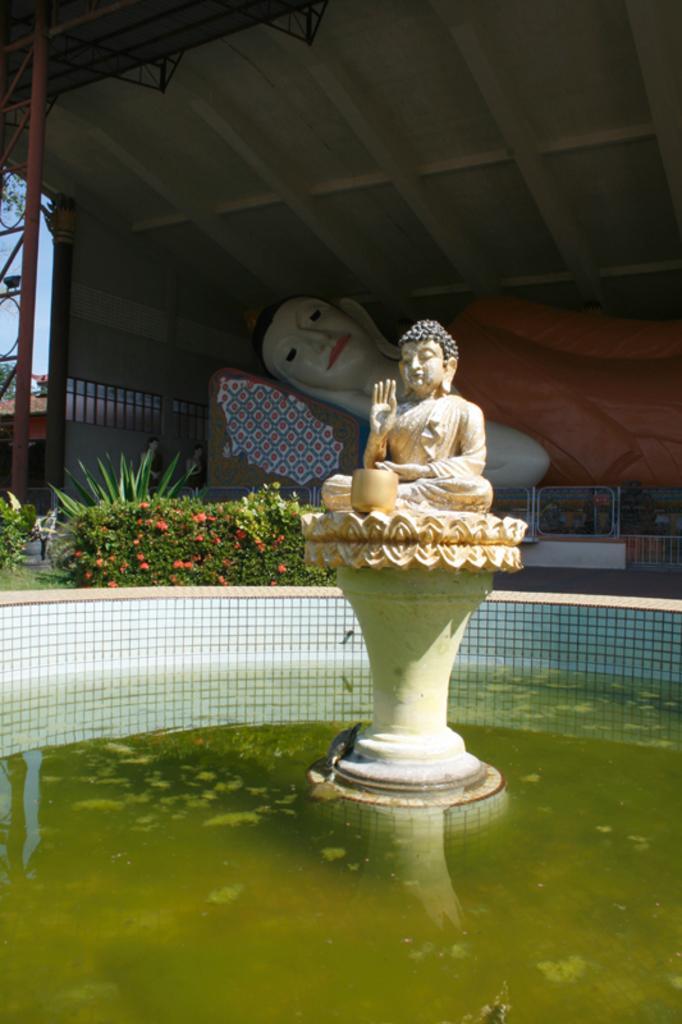Could you give a brief overview of what you see in this image? In this image I can see the water and in the middle of the water I can see a statue of a person sitting. In the background I can see few plants, few flowers, a statue of a person sleeping under the shed and the sky. 